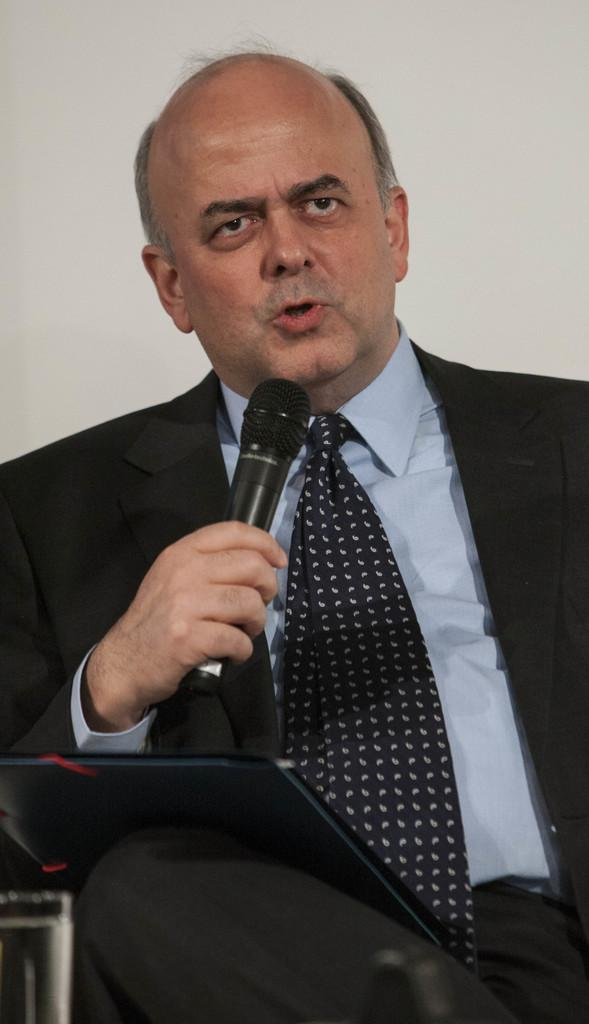Who is the main subject in the image? There is a man in the image. What is the man wearing? The man is wearing a black suit. Where is the man sitting in relation to the image? The man is sitting in front. What is the man doing in the image? The man is giving a speech. What tool is the man using to amplify his voice? The man is using a microphone. What is the color of the background in the image? There is a white background in the image. What type of friction is present between the man's shoes and the floor in the image? There is no information about the man's shoes or the floor in the image, so it is impossible to determine the type of friction present. What disease is the man discussing in his speech? The image does not provide any information about the topic of the man's speech, so it is impossible to determine if he is discussing a disease or any other subject. 